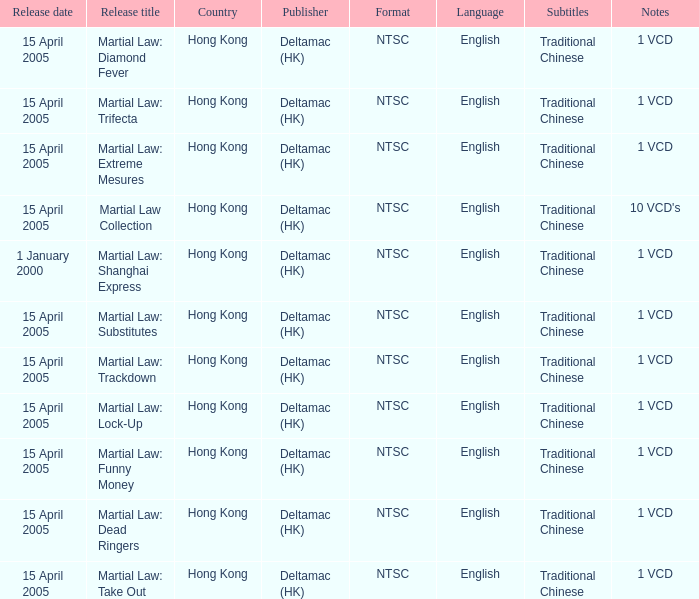Which publisher released Martial Law: Substitutes? Deltamac (HK). Give me the full table as a dictionary. {'header': ['Release date', 'Release title', 'Country', 'Publisher', 'Format', 'Language', 'Subtitles', 'Notes'], 'rows': [['15 April 2005', 'Martial Law: Diamond Fever', 'Hong Kong', 'Deltamac (HK)', 'NTSC', 'English', 'Traditional Chinese', '1 VCD'], ['15 April 2005', 'Martial Law: Trifecta', 'Hong Kong', 'Deltamac (HK)', 'NTSC', 'English', 'Traditional Chinese', '1 VCD'], ['15 April 2005', 'Martial Law: Extreme Mesures', 'Hong Kong', 'Deltamac (HK)', 'NTSC', 'English', 'Traditional Chinese', '1 VCD'], ['15 April 2005', 'Martial Law Collection', 'Hong Kong', 'Deltamac (HK)', 'NTSC', 'English', 'Traditional Chinese', "10 VCD's"], ['1 January 2000', 'Martial Law: Shanghai Express', 'Hong Kong', 'Deltamac (HK)', 'NTSC', 'English', 'Traditional Chinese', '1 VCD'], ['15 April 2005', 'Martial Law: Substitutes', 'Hong Kong', 'Deltamac (HK)', 'NTSC', 'English', 'Traditional Chinese', '1 VCD'], ['15 April 2005', 'Martial Law: Trackdown', 'Hong Kong', 'Deltamac (HK)', 'NTSC', 'English', 'Traditional Chinese', '1 VCD'], ['15 April 2005', 'Martial Law: Lock-Up', 'Hong Kong', 'Deltamac (HK)', 'NTSC', 'English', 'Traditional Chinese', '1 VCD'], ['15 April 2005', 'Martial Law: Funny Money', 'Hong Kong', 'Deltamac (HK)', 'NTSC', 'English', 'Traditional Chinese', '1 VCD'], ['15 April 2005', 'Martial Law: Dead Ringers', 'Hong Kong', 'Deltamac (HK)', 'NTSC', 'English', 'Traditional Chinese', '1 VCD'], ['15 April 2005', 'Martial Law: Take Out', 'Hong Kong', 'Deltamac (HK)', 'NTSC', 'English', 'Traditional Chinese', '1 VCD']]} 